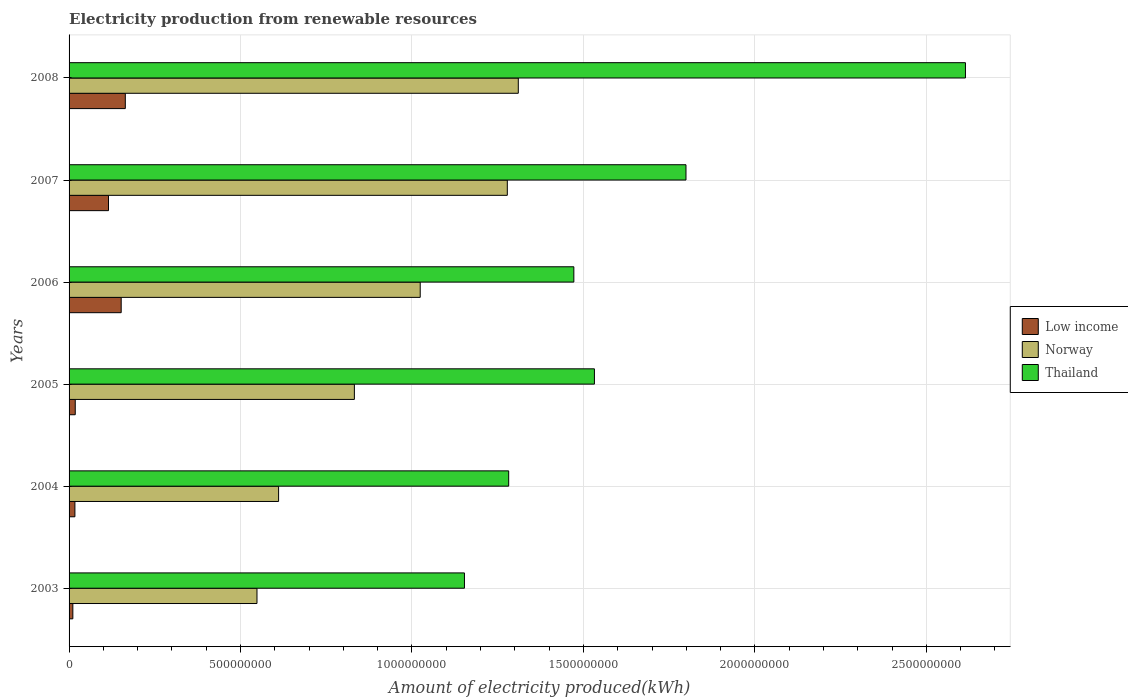How many different coloured bars are there?
Keep it short and to the point. 3. How many groups of bars are there?
Your answer should be very brief. 6. Are the number of bars per tick equal to the number of legend labels?
Give a very brief answer. Yes. What is the amount of electricity produced in Thailand in 2004?
Ensure brevity in your answer.  1.28e+09. Across all years, what is the maximum amount of electricity produced in Low income?
Provide a short and direct response. 1.64e+08. Across all years, what is the minimum amount of electricity produced in Low income?
Make the answer very short. 1.10e+07. In which year was the amount of electricity produced in Thailand minimum?
Give a very brief answer. 2003. What is the total amount of electricity produced in Low income in the graph?
Provide a succinct answer. 4.77e+08. What is the difference between the amount of electricity produced in Thailand in 2004 and that in 2006?
Provide a succinct answer. -1.90e+08. What is the difference between the amount of electricity produced in Thailand in 2005 and the amount of electricity produced in Low income in 2003?
Keep it short and to the point. 1.52e+09. What is the average amount of electricity produced in Norway per year?
Keep it short and to the point. 9.34e+08. In the year 2006, what is the difference between the amount of electricity produced in Low income and amount of electricity produced in Norway?
Make the answer very short. -8.72e+08. In how many years, is the amount of electricity produced in Thailand greater than 100000000 kWh?
Ensure brevity in your answer.  6. What is the ratio of the amount of electricity produced in Thailand in 2003 to that in 2006?
Provide a short and direct response. 0.78. Is the amount of electricity produced in Thailand in 2003 less than that in 2008?
Provide a short and direct response. Yes. What is the difference between the highest and the second highest amount of electricity produced in Low income?
Keep it short and to the point. 1.20e+07. What is the difference between the highest and the lowest amount of electricity produced in Low income?
Provide a short and direct response. 1.53e+08. In how many years, is the amount of electricity produced in Norway greater than the average amount of electricity produced in Norway taken over all years?
Make the answer very short. 3. Is the sum of the amount of electricity produced in Norway in 2003 and 2005 greater than the maximum amount of electricity produced in Thailand across all years?
Offer a terse response. No. What does the 2nd bar from the top in 2004 represents?
Your response must be concise. Norway. What does the 3rd bar from the bottom in 2007 represents?
Your answer should be very brief. Thailand. Is it the case that in every year, the sum of the amount of electricity produced in Thailand and amount of electricity produced in Norway is greater than the amount of electricity produced in Low income?
Offer a terse response. Yes. How many bars are there?
Your response must be concise. 18. How many years are there in the graph?
Make the answer very short. 6. What is the difference between two consecutive major ticks on the X-axis?
Offer a terse response. 5.00e+08. Does the graph contain any zero values?
Provide a short and direct response. No. Does the graph contain grids?
Ensure brevity in your answer.  Yes. Where does the legend appear in the graph?
Your answer should be compact. Center right. How many legend labels are there?
Provide a short and direct response. 3. What is the title of the graph?
Offer a terse response. Electricity production from renewable resources. Does "Malaysia" appear as one of the legend labels in the graph?
Ensure brevity in your answer.  No. What is the label or title of the X-axis?
Ensure brevity in your answer.  Amount of electricity produced(kWh). What is the label or title of the Y-axis?
Give a very brief answer. Years. What is the Amount of electricity produced(kWh) of Low income in 2003?
Offer a very short reply. 1.10e+07. What is the Amount of electricity produced(kWh) of Norway in 2003?
Your response must be concise. 5.48e+08. What is the Amount of electricity produced(kWh) in Thailand in 2003?
Keep it short and to the point. 1.15e+09. What is the Amount of electricity produced(kWh) of Low income in 2004?
Offer a very short reply. 1.70e+07. What is the Amount of electricity produced(kWh) of Norway in 2004?
Provide a succinct answer. 6.11e+08. What is the Amount of electricity produced(kWh) of Thailand in 2004?
Offer a very short reply. 1.28e+09. What is the Amount of electricity produced(kWh) in Low income in 2005?
Ensure brevity in your answer.  1.80e+07. What is the Amount of electricity produced(kWh) in Norway in 2005?
Offer a terse response. 8.32e+08. What is the Amount of electricity produced(kWh) of Thailand in 2005?
Offer a very short reply. 1.53e+09. What is the Amount of electricity produced(kWh) of Low income in 2006?
Your answer should be compact. 1.52e+08. What is the Amount of electricity produced(kWh) in Norway in 2006?
Keep it short and to the point. 1.02e+09. What is the Amount of electricity produced(kWh) of Thailand in 2006?
Make the answer very short. 1.47e+09. What is the Amount of electricity produced(kWh) in Low income in 2007?
Make the answer very short. 1.15e+08. What is the Amount of electricity produced(kWh) in Norway in 2007?
Keep it short and to the point. 1.28e+09. What is the Amount of electricity produced(kWh) in Thailand in 2007?
Your answer should be compact. 1.80e+09. What is the Amount of electricity produced(kWh) of Low income in 2008?
Give a very brief answer. 1.64e+08. What is the Amount of electricity produced(kWh) of Norway in 2008?
Your answer should be very brief. 1.31e+09. What is the Amount of electricity produced(kWh) in Thailand in 2008?
Your answer should be very brief. 2.61e+09. Across all years, what is the maximum Amount of electricity produced(kWh) of Low income?
Your answer should be very brief. 1.64e+08. Across all years, what is the maximum Amount of electricity produced(kWh) in Norway?
Provide a short and direct response. 1.31e+09. Across all years, what is the maximum Amount of electricity produced(kWh) in Thailand?
Offer a terse response. 2.61e+09. Across all years, what is the minimum Amount of electricity produced(kWh) in Low income?
Your answer should be compact. 1.10e+07. Across all years, what is the minimum Amount of electricity produced(kWh) of Norway?
Make the answer very short. 5.48e+08. Across all years, what is the minimum Amount of electricity produced(kWh) in Thailand?
Your response must be concise. 1.15e+09. What is the total Amount of electricity produced(kWh) of Low income in the graph?
Offer a terse response. 4.77e+08. What is the total Amount of electricity produced(kWh) in Norway in the graph?
Make the answer very short. 5.60e+09. What is the total Amount of electricity produced(kWh) in Thailand in the graph?
Make the answer very short. 9.85e+09. What is the difference between the Amount of electricity produced(kWh) in Low income in 2003 and that in 2004?
Keep it short and to the point. -6.00e+06. What is the difference between the Amount of electricity produced(kWh) of Norway in 2003 and that in 2004?
Make the answer very short. -6.30e+07. What is the difference between the Amount of electricity produced(kWh) in Thailand in 2003 and that in 2004?
Give a very brief answer. -1.29e+08. What is the difference between the Amount of electricity produced(kWh) of Low income in 2003 and that in 2005?
Provide a short and direct response. -7.00e+06. What is the difference between the Amount of electricity produced(kWh) of Norway in 2003 and that in 2005?
Your response must be concise. -2.84e+08. What is the difference between the Amount of electricity produced(kWh) in Thailand in 2003 and that in 2005?
Make the answer very short. -3.79e+08. What is the difference between the Amount of electricity produced(kWh) in Low income in 2003 and that in 2006?
Make the answer very short. -1.41e+08. What is the difference between the Amount of electricity produced(kWh) in Norway in 2003 and that in 2006?
Offer a very short reply. -4.76e+08. What is the difference between the Amount of electricity produced(kWh) of Thailand in 2003 and that in 2006?
Ensure brevity in your answer.  -3.19e+08. What is the difference between the Amount of electricity produced(kWh) of Low income in 2003 and that in 2007?
Your answer should be very brief. -1.04e+08. What is the difference between the Amount of electricity produced(kWh) in Norway in 2003 and that in 2007?
Your answer should be compact. -7.30e+08. What is the difference between the Amount of electricity produced(kWh) of Thailand in 2003 and that in 2007?
Your answer should be very brief. -6.46e+08. What is the difference between the Amount of electricity produced(kWh) in Low income in 2003 and that in 2008?
Your answer should be very brief. -1.53e+08. What is the difference between the Amount of electricity produced(kWh) in Norway in 2003 and that in 2008?
Provide a succinct answer. -7.62e+08. What is the difference between the Amount of electricity produced(kWh) of Thailand in 2003 and that in 2008?
Your answer should be compact. -1.46e+09. What is the difference between the Amount of electricity produced(kWh) in Low income in 2004 and that in 2005?
Your response must be concise. -1.00e+06. What is the difference between the Amount of electricity produced(kWh) of Norway in 2004 and that in 2005?
Offer a terse response. -2.21e+08. What is the difference between the Amount of electricity produced(kWh) in Thailand in 2004 and that in 2005?
Your response must be concise. -2.50e+08. What is the difference between the Amount of electricity produced(kWh) in Low income in 2004 and that in 2006?
Ensure brevity in your answer.  -1.35e+08. What is the difference between the Amount of electricity produced(kWh) in Norway in 2004 and that in 2006?
Offer a very short reply. -4.13e+08. What is the difference between the Amount of electricity produced(kWh) of Thailand in 2004 and that in 2006?
Provide a succinct answer. -1.90e+08. What is the difference between the Amount of electricity produced(kWh) of Low income in 2004 and that in 2007?
Provide a succinct answer. -9.80e+07. What is the difference between the Amount of electricity produced(kWh) in Norway in 2004 and that in 2007?
Provide a succinct answer. -6.67e+08. What is the difference between the Amount of electricity produced(kWh) in Thailand in 2004 and that in 2007?
Keep it short and to the point. -5.17e+08. What is the difference between the Amount of electricity produced(kWh) of Low income in 2004 and that in 2008?
Offer a very short reply. -1.47e+08. What is the difference between the Amount of electricity produced(kWh) of Norway in 2004 and that in 2008?
Offer a terse response. -6.99e+08. What is the difference between the Amount of electricity produced(kWh) in Thailand in 2004 and that in 2008?
Your answer should be very brief. -1.33e+09. What is the difference between the Amount of electricity produced(kWh) of Low income in 2005 and that in 2006?
Your response must be concise. -1.34e+08. What is the difference between the Amount of electricity produced(kWh) of Norway in 2005 and that in 2006?
Provide a short and direct response. -1.92e+08. What is the difference between the Amount of electricity produced(kWh) of Thailand in 2005 and that in 2006?
Offer a very short reply. 6.00e+07. What is the difference between the Amount of electricity produced(kWh) of Low income in 2005 and that in 2007?
Ensure brevity in your answer.  -9.70e+07. What is the difference between the Amount of electricity produced(kWh) in Norway in 2005 and that in 2007?
Give a very brief answer. -4.46e+08. What is the difference between the Amount of electricity produced(kWh) of Thailand in 2005 and that in 2007?
Provide a succinct answer. -2.67e+08. What is the difference between the Amount of electricity produced(kWh) in Low income in 2005 and that in 2008?
Keep it short and to the point. -1.46e+08. What is the difference between the Amount of electricity produced(kWh) in Norway in 2005 and that in 2008?
Your answer should be compact. -4.78e+08. What is the difference between the Amount of electricity produced(kWh) of Thailand in 2005 and that in 2008?
Give a very brief answer. -1.08e+09. What is the difference between the Amount of electricity produced(kWh) in Low income in 2006 and that in 2007?
Offer a very short reply. 3.70e+07. What is the difference between the Amount of electricity produced(kWh) in Norway in 2006 and that in 2007?
Provide a succinct answer. -2.54e+08. What is the difference between the Amount of electricity produced(kWh) of Thailand in 2006 and that in 2007?
Your answer should be very brief. -3.27e+08. What is the difference between the Amount of electricity produced(kWh) in Low income in 2006 and that in 2008?
Ensure brevity in your answer.  -1.20e+07. What is the difference between the Amount of electricity produced(kWh) of Norway in 2006 and that in 2008?
Offer a very short reply. -2.86e+08. What is the difference between the Amount of electricity produced(kWh) of Thailand in 2006 and that in 2008?
Your answer should be compact. -1.14e+09. What is the difference between the Amount of electricity produced(kWh) of Low income in 2007 and that in 2008?
Your answer should be compact. -4.90e+07. What is the difference between the Amount of electricity produced(kWh) of Norway in 2007 and that in 2008?
Your response must be concise. -3.20e+07. What is the difference between the Amount of electricity produced(kWh) in Thailand in 2007 and that in 2008?
Keep it short and to the point. -8.15e+08. What is the difference between the Amount of electricity produced(kWh) in Low income in 2003 and the Amount of electricity produced(kWh) in Norway in 2004?
Keep it short and to the point. -6.00e+08. What is the difference between the Amount of electricity produced(kWh) in Low income in 2003 and the Amount of electricity produced(kWh) in Thailand in 2004?
Your answer should be compact. -1.27e+09. What is the difference between the Amount of electricity produced(kWh) in Norway in 2003 and the Amount of electricity produced(kWh) in Thailand in 2004?
Offer a terse response. -7.34e+08. What is the difference between the Amount of electricity produced(kWh) in Low income in 2003 and the Amount of electricity produced(kWh) in Norway in 2005?
Give a very brief answer. -8.21e+08. What is the difference between the Amount of electricity produced(kWh) in Low income in 2003 and the Amount of electricity produced(kWh) in Thailand in 2005?
Offer a very short reply. -1.52e+09. What is the difference between the Amount of electricity produced(kWh) of Norway in 2003 and the Amount of electricity produced(kWh) of Thailand in 2005?
Make the answer very short. -9.84e+08. What is the difference between the Amount of electricity produced(kWh) of Low income in 2003 and the Amount of electricity produced(kWh) of Norway in 2006?
Provide a short and direct response. -1.01e+09. What is the difference between the Amount of electricity produced(kWh) in Low income in 2003 and the Amount of electricity produced(kWh) in Thailand in 2006?
Make the answer very short. -1.46e+09. What is the difference between the Amount of electricity produced(kWh) in Norway in 2003 and the Amount of electricity produced(kWh) in Thailand in 2006?
Give a very brief answer. -9.24e+08. What is the difference between the Amount of electricity produced(kWh) of Low income in 2003 and the Amount of electricity produced(kWh) of Norway in 2007?
Provide a short and direct response. -1.27e+09. What is the difference between the Amount of electricity produced(kWh) of Low income in 2003 and the Amount of electricity produced(kWh) of Thailand in 2007?
Give a very brief answer. -1.79e+09. What is the difference between the Amount of electricity produced(kWh) of Norway in 2003 and the Amount of electricity produced(kWh) of Thailand in 2007?
Offer a very short reply. -1.25e+09. What is the difference between the Amount of electricity produced(kWh) in Low income in 2003 and the Amount of electricity produced(kWh) in Norway in 2008?
Keep it short and to the point. -1.30e+09. What is the difference between the Amount of electricity produced(kWh) of Low income in 2003 and the Amount of electricity produced(kWh) of Thailand in 2008?
Your response must be concise. -2.60e+09. What is the difference between the Amount of electricity produced(kWh) in Norway in 2003 and the Amount of electricity produced(kWh) in Thailand in 2008?
Ensure brevity in your answer.  -2.07e+09. What is the difference between the Amount of electricity produced(kWh) in Low income in 2004 and the Amount of electricity produced(kWh) in Norway in 2005?
Your response must be concise. -8.15e+08. What is the difference between the Amount of electricity produced(kWh) in Low income in 2004 and the Amount of electricity produced(kWh) in Thailand in 2005?
Offer a very short reply. -1.52e+09. What is the difference between the Amount of electricity produced(kWh) of Norway in 2004 and the Amount of electricity produced(kWh) of Thailand in 2005?
Provide a succinct answer. -9.21e+08. What is the difference between the Amount of electricity produced(kWh) in Low income in 2004 and the Amount of electricity produced(kWh) in Norway in 2006?
Offer a very short reply. -1.01e+09. What is the difference between the Amount of electricity produced(kWh) in Low income in 2004 and the Amount of electricity produced(kWh) in Thailand in 2006?
Your answer should be very brief. -1.46e+09. What is the difference between the Amount of electricity produced(kWh) in Norway in 2004 and the Amount of electricity produced(kWh) in Thailand in 2006?
Offer a terse response. -8.61e+08. What is the difference between the Amount of electricity produced(kWh) in Low income in 2004 and the Amount of electricity produced(kWh) in Norway in 2007?
Ensure brevity in your answer.  -1.26e+09. What is the difference between the Amount of electricity produced(kWh) in Low income in 2004 and the Amount of electricity produced(kWh) in Thailand in 2007?
Give a very brief answer. -1.78e+09. What is the difference between the Amount of electricity produced(kWh) in Norway in 2004 and the Amount of electricity produced(kWh) in Thailand in 2007?
Your response must be concise. -1.19e+09. What is the difference between the Amount of electricity produced(kWh) of Low income in 2004 and the Amount of electricity produced(kWh) of Norway in 2008?
Your answer should be compact. -1.29e+09. What is the difference between the Amount of electricity produced(kWh) of Low income in 2004 and the Amount of electricity produced(kWh) of Thailand in 2008?
Offer a terse response. -2.60e+09. What is the difference between the Amount of electricity produced(kWh) of Norway in 2004 and the Amount of electricity produced(kWh) of Thailand in 2008?
Provide a short and direct response. -2.00e+09. What is the difference between the Amount of electricity produced(kWh) in Low income in 2005 and the Amount of electricity produced(kWh) in Norway in 2006?
Your answer should be compact. -1.01e+09. What is the difference between the Amount of electricity produced(kWh) of Low income in 2005 and the Amount of electricity produced(kWh) of Thailand in 2006?
Provide a succinct answer. -1.45e+09. What is the difference between the Amount of electricity produced(kWh) of Norway in 2005 and the Amount of electricity produced(kWh) of Thailand in 2006?
Offer a terse response. -6.40e+08. What is the difference between the Amount of electricity produced(kWh) of Low income in 2005 and the Amount of electricity produced(kWh) of Norway in 2007?
Your response must be concise. -1.26e+09. What is the difference between the Amount of electricity produced(kWh) in Low income in 2005 and the Amount of electricity produced(kWh) in Thailand in 2007?
Make the answer very short. -1.78e+09. What is the difference between the Amount of electricity produced(kWh) of Norway in 2005 and the Amount of electricity produced(kWh) of Thailand in 2007?
Offer a terse response. -9.67e+08. What is the difference between the Amount of electricity produced(kWh) in Low income in 2005 and the Amount of electricity produced(kWh) in Norway in 2008?
Ensure brevity in your answer.  -1.29e+09. What is the difference between the Amount of electricity produced(kWh) in Low income in 2005 and the Amount of electricity produced(kWh) in Thailand in 2008?
Make the answer very short. -2.60e+09. What is the difference between the Amount of electricity produced(kWh) of Norway in 2005 and the Amount of electricity produced(kWh) of Thailand in 2008?
Give a very brief answer. -1.78e+09. What is the difference between the Amount of electricity produced(kWh) of Low income in 2006 and the Amount of electricity produced(kWh) of Norway in 2007?
Ensure brevity in your answer.  -1.13e+09. What is the difference between the Amount of electricity produced(kWh) in Low income in 2006 and the Amount of electricity produced(kWh) in Thailand in 2007?
Your answer should be very brief. -1.65e+09. What is the difference between the Amount of electricity produced(kWh) of Norway in 2006 and the Amount of electricity produced(kWh) of Thailand in 2007?
Your answer should be compact. -7.75e+08. What is the difference between the Amount of electricity produced(kWh) in Low income in 2006 and the Amount of electricity produced(kWh) in Norway in 2008?
Offer a very short reply. -1.16e+09. What is the difference between the Amount of electricity produced(kWh) in Low income in 2006 and the Amount of electricity produced(kWh) in Thailand in 2008?
Your answer should be compact. -2.46e+09. What is the difference between the Amount of electricity produced(kWh) of Norway in 2006 and the Amount of electricity produced(kWh) of Thailand in 2008?
Ensure brevity in your answer.  -1.59e+09. What is the difference between the Amount of electricity produced(kWh) of Low income in 2007 and the Amount of electricity produced(kWh) of Norway in 2008?
Your answer should be compact. -1.20e+09. What is the difference between the Amount of electricity produced(kWh) in Low income in 2007 and the Amount of electricity produced(kWh) in Thailand in 2008?
Provide a short and direct response. -2.50e+09. What is the difference between the Amount of electricity produced(kWh) in Norway in 2007 and the Amount of electricity produced(kWh) in Thailand in 2008?
Offer a terse response. -1.34e+09. What is the average Amount of electricity produced(kWh) of Low income per year?
Your answer should be very brief. 7.95e+07. What is the average Amount of electricity produced(kWh) in Norway per year?
Make the answer very short. 9.34e+08. What is the average Amount of electricity produced(kWh) of Thailand per year?
Keep it short and to the point. 1.64e+09. In the year 2003, what is the difference between the Amount of electricity produced(kWh) of Low income and Amount of electricity produced(kWh) of Norway?
Offer a very short reply. -5.37e+08. In the year 2003, what is the difference between the Amount of electricity produced(kWh) of Low income and Amount of electricity produced(kWh) of Thailand?
Ensure brevity in your answer.  -1.14e+09. In the year 2003, what is the difference between the Amount of electricity produced(kWh) in Norway and Amount of electricity produced(kWh) in Thailand?
Provide a succinct answer. -6.05e+08. In the year 2004, what is the difference between the Amount of electricity produced(kWh) in Low income and Amount of electricity produced(kWh) in Norway?
Offer a terse response. -5.94e+08. In the year 2004, what is the difference between the Amount of electricity produced(kWh) in Low income and Amount of electricity produced(kWh) in Thailand?
Provide a succinct answer. -1.26e+09. In the year 2004, what is the difference between the Amount of electricity produced(kWh) of Norway and Amount of electricity produced(kWh) of Thailand?
Your response must be concise. -6.71e+08. In the year 2005, what is the difference between the Amount of electricity produced(kWh) in Low income and Amount of electricity produced(kWh) in Norway?
Ensure brevity in your answer.  -8.14e+08. In the year 2005, what is the difference between the Amount of electricity produced(kWh) in Low income and Amount of electricity produced(kWh) in Thailand?
Provide a succinct answer. -1.51e+09. In the year 2005, what is the difference between the Amount of electricity produced(kWh) of Norway and Amount of electricity produced(kWh) of Thailand?
Your answer should be very brief. -7.00e+08. In the year 2006, what is the difference between the Amount of electricity produced(kWh) of Low income and Amount of electricity produced(kWh) of Norway?
Ensure brevity in your answer.  -8.72e+08. In the year 2006, what is the difference between the Amount of electricity produced(kWh) of Low income and Amount of electricity produced(kWh) of Thailand?
Ensure brevity in your answer.  -1.32e+09. In the year 2006, what is the difference between the Amount of electricity produced(kWh) of Norway and Amount of electricity produced(kWh) of Thailand?
Provide a succinct answer. -4.48e+08. In the year 2007, what is the difference between the Amount of electricity produced(kWh) of Low income and Amount of electricity produced(kWh) of Norway?
Keep it short and to the point. -1.16e+09. In the year 2007, what is the difference between the Amount of electricity produced(kWh) of Low income and Amount of electricity produced(kWh) of Thailand?
Ensure brevity in your answer.  -1.68e+09. In the year 2007, what is the difference between the Amount of electricity produced(kWh) of Norway and Amount of electricity produced(kWh) of Thailand?
Give a very brief answer. -5.21e+08. In the year 2008, what is the difference between the Amount of electricity produced(kWh) of Low income and Amount of electricity produced(kWh) of Norway?
Your response must be concise. -1.15e+09. In the year 2008, what is the difference between the Amount of electricity produced(kWh) of Low income and Amount of electricity produced(kWh) of Thailand?
Ensure brevity in your answer.  -2.45e+09. In the year 2008, what is the difference between the Amount of electricity produced(kWh) in Norway and Amount of electricity produced(kWh) in Thailand?
Offer a terse response. -1.30e+09. What is the ratio of the Amount of electricity produced(kWh) in Low income in 2003 to that in 2004?
Ensure brevity in your answer.  0.65. What is the ratio of the Amount of electricity produced(kWh) in Norway in 2003 to that in 2004?
Your answer should be compact. 0.9. What is the ratio of the Amount of electricity produced(kWh) in Thailand in 2003 to that in 2004?
Your response must be concise. 0.9. What is the ratio of the Amount of electricity produced(kWh) of Low income in 2003 to that in 2005?
Provide a succinct answer. 0.61. What is the ratio of the Amount of electricity produced(kWh) in Norway in 2003 to that in 2005?
Ensure brevity in your answer.  0.66. What is the ratio of the Amount of electricity produced(kWh) of Thailand in 2003 to that in 2005?
Provide a short and direct response. 0.75. What is the ratio of the Amount of electricity produced(kWh) in Low income in 2003 to that in 2006?
Your answer should be compact. 0.07. What is the ratio of the Amount of electricity produced(kWh) in Norway in 2003 to that in 2006?
Your response must be concise. 0.54. What is the ratio of the Amount of electricity produced(kWh) of Thailand in 2003 to that in 2006?
Keep it short and to the point. 0.78. What is the ratio of the Amount of electricity produced(kWh) in Low income in 2003 to that in 2007?
Give a very brief answer. 0.1. What is the ratio of the Amount of electricity produced(kWh) in Norway in 2003 to that in 2007?
Keep it short and to the point. 0.43. What is the ratio of the Amount of electricity produced(kWh) of Thailand in 2003 to that in 2007?
Your answer should be very brief. 0.64. What is the ratio of the Amount of electricity produced(kWh) in Low income in 2003 to that in 2008?
Provide a short and direct response. 0.07. What is the ratio of the Amount of electricity produced(kWh) of Norway in 2003 to that in 2008?
Your answer should be compact. 0.42. What is the ratio of the Amount of electricity produced(kWh) of Thailand in 2003 to that in 2008?
Your answer should be compact. 0.44. What is the ratio of the Amount of electricity produced(kWh) in Low income in 2004 to that in 2005?
Keep it short and to the point. 0.94. What is the ratio of the Amount of electricity produced(kWh) of Norway in 2004 to that in 2005?
Make the answer very short. 0.73. What is the ratio of the Amount of electricity produced(kWh) of Thailand in 2004 to that in 2005?
Ensure brevity in your answer.  0.84. What is the ratio of the Amount of electricity produced(kWh) of Low income in 2004 to that in 2006?
Keep it short and to the point. 0.11. What is the ratio of the Amount of electricity produced(kWh) in Norway in 2004 to that in 2006?
Provide a short and direct response. 0.6. What is the ratio of the Amount of electricity produced(kWh) of Thailand in 2004 to that in 2006?
Offer a terse response. 0.87. What is the ratio of the Amount of electricity produced(kWh) of Low income in 2004 to that in 2007?
Provide a short and direct response. 0.15. What is the ratio of the Amount of electricity produced(kWh) of Norway in 2004 to that in 2007?
Give a very brief answer. 0.48. What is the ratio of the Amount of electricity produced(kWh) of Thailand in 2004 to that in 2007?
Make the answer very short. 0.71. What is the ratio of the Amount of electricity produced(kWh) in Low income in 2004 to that in 2008?
Offer a terse response. 0.1. What is the ratio of the Amount of electricity produced(kWh) in Norway in 2004 to that in 2008?
Offer a terse response. 0.47. What is the ratio of the Amount of electricity produced(kWh) of Thailand in 2004 to that in 2008?
Offer a very short reply. 0.49. What is the ratio of the Amount of electricity produced(kWh) in Low income in 2005 to that in 2006?
Your response must be concise. 0.12. What is the ratio of the Amount of electricity produced(kWh) of Norway in 2005 to that in 2006?
Provide a succinct answer. 0.81. What is the ratio of the Amount of electricity produced(kWh) in Thailand in 2005 to that in 2006?
Provide a short and direct response. 1.04. What is the ratio of the Amount of electricity produced(kWh) in Low income in 2005 to that in 2007?
Ensure brevity in your answer.  0.16. What is the ratio of the Amount of electricity produced(kWh) of Norway in 2005 to that in 2007?
Offer a terse response. 0.65. What is the ratio of the Amount of electricity produced(kWh) of Thailand in 2005 to that in 2007?
Your response must be concise. 0.85. What is the ratio of the Amount of electricity produced(kWh) in Low income in 2005 to that in 2008?
Offer a terse response. 0.11. What is the ratio of the Amount of electricity produced(kWh) of Norway in 2005 to that in 2008?
Keep it short and to the point. 0.64. What is the ratio of the Amount of electricity produced(kWh) in Thailand in 2005 to that in 2008?
Make the answer very short. 0.59. What is the ratio of the Amount of electricity produced(kWh) of Low income in 2006 to that in 2007?
Ensure brevity in your answer.  1.32. What is the ratio of the Amount of electricity produced(kWh) in Norway in 2006 to that in 2007?
Offer a very short reply. 0.8. What is the ratio of the Amount of electricity produced(kWh) in Thailand in 2006 to that in 2007?
Your answer should be very brief. 0.82. What is the ratio of the Amount of electricity produced(kWh) of Low income in 2006 to that in 2008?
Offer a very short reply. 0.93. What is the ratio of the Amount of electricity produced(kWh) in Norway in 2006 to that in 2008?
Keep it short and to the point. 0.78. What is the ratio of the Amount of electricity produced(kWh) in Thailand in 2006 to that in 2008?
Offer a very short reply. 0.56. What is the ratio of the Amount of electricity produced(kWh) in Low income in 2007 to that in 2008?
Ensure brevity in your answer.  0.7. What is the ratio of the Amount of electricity produced(kWh) of Norway in 2007 to that in 2008?
Your response must be concise. 0.98. What is the ratio of the Amount of electricity produced(kWh) of Thailand in 2007 to that in 2008?
Your answer should be very brief. 0.69. What is the difference between the highest and the second highest Amount of electricity produced(kWh) in Low income?
Give a very brief answer. 1.20e+07. What is the difference between the highest and the second highest Amount of electricity produced(kWh) of Norway?
Provide a succinct answer. 3.20e+07. What is the difference between the highest and the second highest Amount of electricity produced(kWh) of Thailand?
Provide a succinct answer. 8.15e+08. What is the difference between the highest and the lowest Amount of electricity produced(kWh) in Low income?
Your response must be concise. 1.53e+08. What is the difference between the highest and the lowest Amount of electricity produced(kWh) in Norway?
Offer a terse response. 7.62e+08. What is the difference between the highest and the lowest Amount of electricity produced(kWh) in Thailand?
Your answer should be compact. 1.46e+09. 